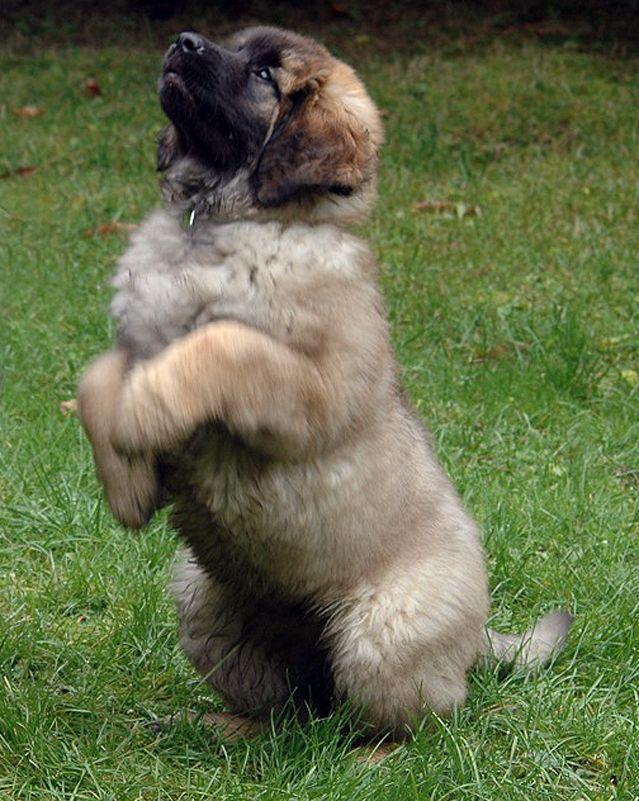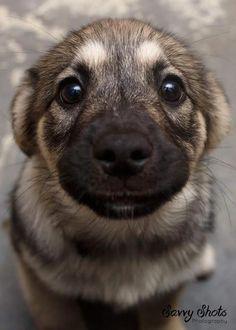The first image is the image on the left, the second image is the image on the right. Examine the images to the left and right. Is the description "A dog is looking to the left" accurate? Answer yes or no. Yes. The first image is the image on the left, the second image is the image on the right. For the images displayed, is the sentence "One of the dogs is laying down with its head on the floor." factually correct? Answer yes or no. No. 